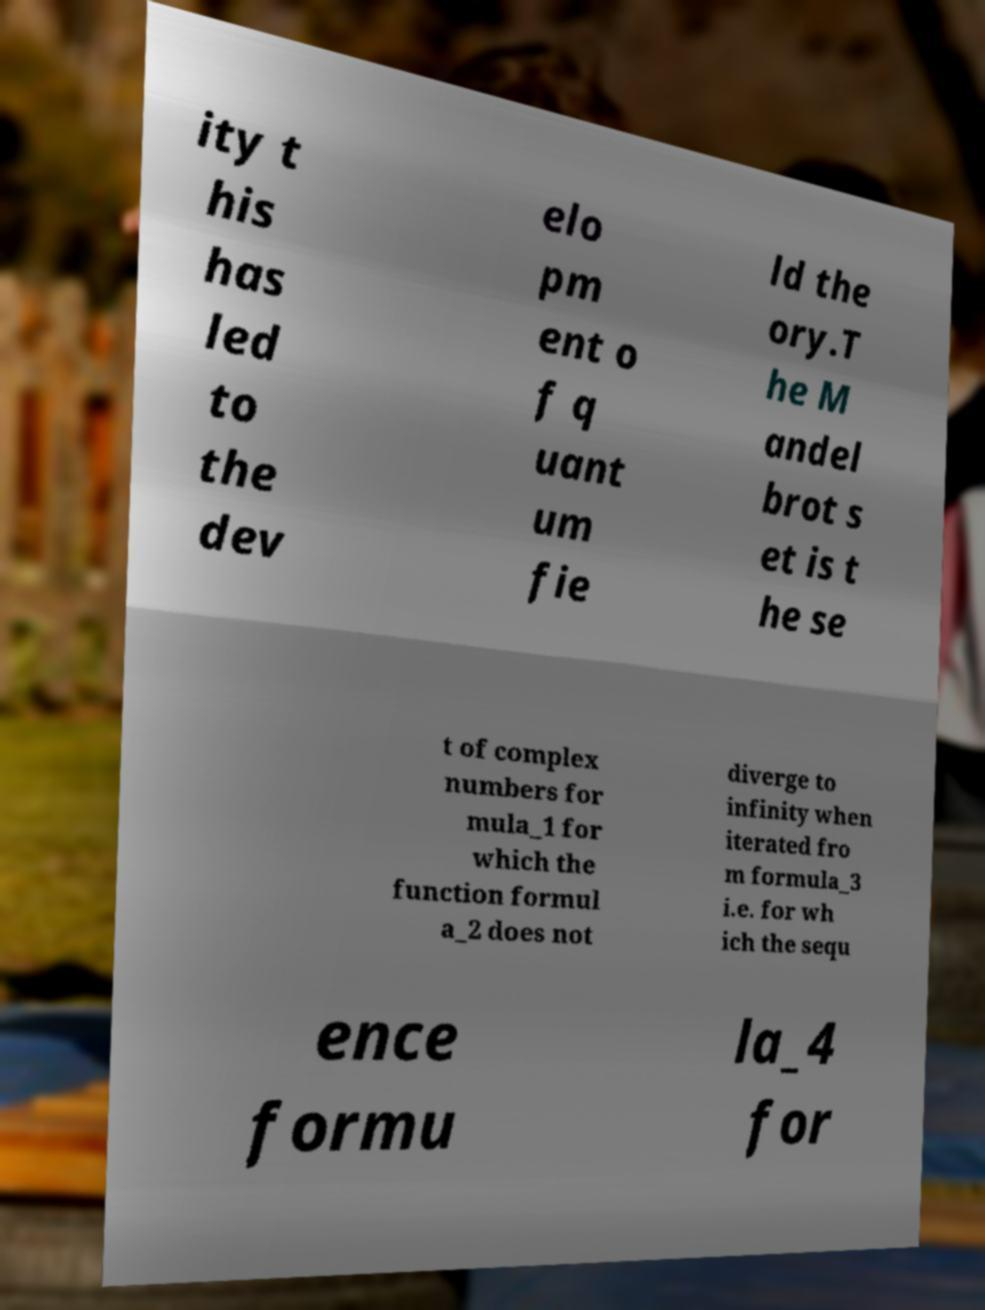Could you extract and type out the text from this image? ity t his has led to the dev elo pm ent o f q uant um fie ld the ory.T he M andel brot s et is t he se t of complex numbers for mula_1 for which the function formul a_2 does not diverge to infinity when iterated fro m formula_3 i.e. for wh ich the sequ ence formu la_4 for 